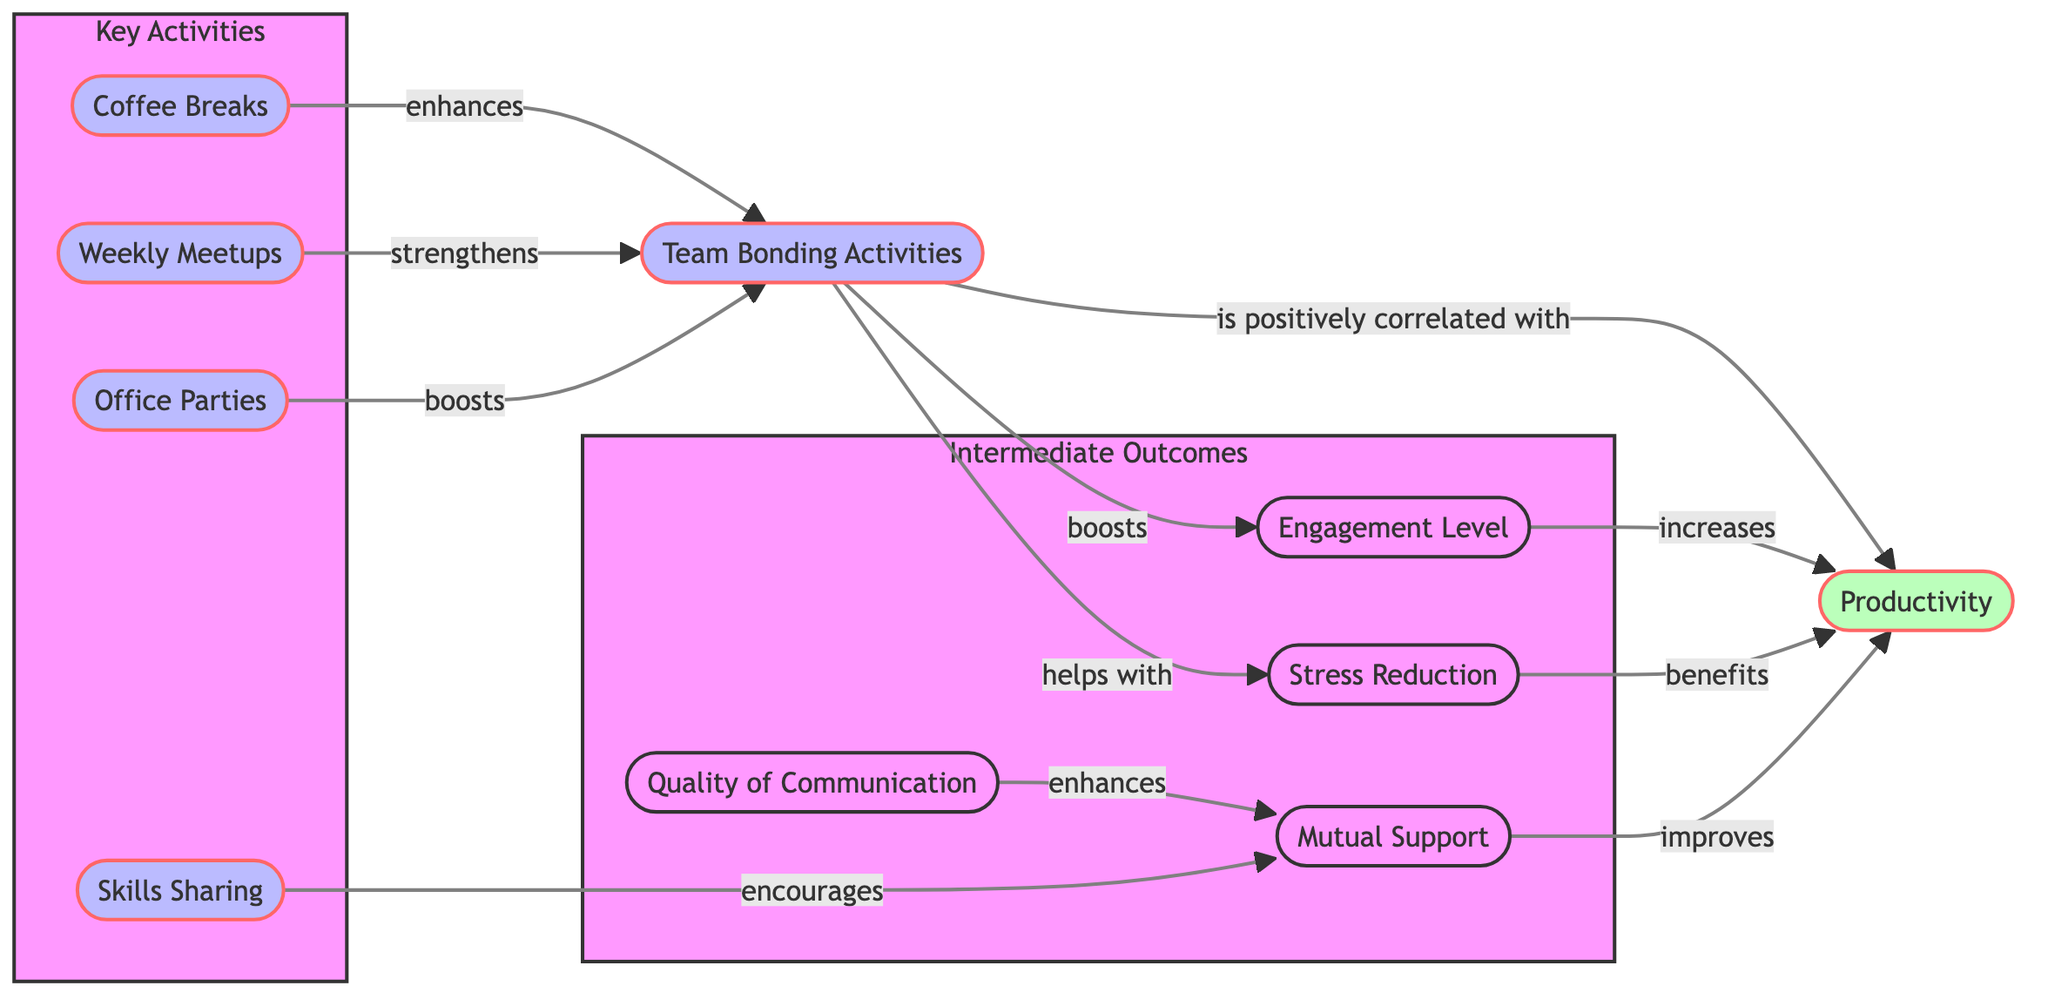What are the main bonding activities mentioned in the diagram? The diagram lists coffee breaks, weekly meetups, office parties, and skills sharing as the main bonding activities under the Key Activities subgraph.
Answer: coffee breaks, weekly meetups, office parties, skills sharing How many outcomes are shown in the diagram? The diagram indicates four outcomes under the Intermediate Outcomes subgraph: mutual support, communication quality, engagement level, and stress reduction.
Answer: four What enhances team bonding according to the diagram? Coffee breaks are shown to enhance team bonding directly in the diagram.
Answer: coffee breaks Which activity is linked to improving productivity through mutual support? The diagram shows that skills sharing encourages mutual support, which in turn improves productivity.
Answer: skills sharing How does team bonding relate to engagement level? According to the diagram, team bonding boosts engagement level, indicating a positive relationship between the two.
Answer: boosts What is the relationship between productivity and team bonding activities? The diagram explicitly states that team bonding activities are positively correlated with productivity, highlighting their impact on performance.
Answer: positively correlated Which intermediate outcome is directly linked to stress reduction? The diagram indicates that stress reduction benefits productivity, showing a direct connection between the two.
Answer: benefits What is the initial node indicating the overall focus of the diagram? The initial node representing the overall focus of the diagram is labeled "Productivity," which is the outcome of interest.
Answer: Productivity Which activity specifically enhances communication quality? The diagram indicates that mutual support enhances communication quality, suggesting a connection between these elements.
Answer: mutual support What contributes to the improvement of mutual support? Communication quality enhances mutual support as shown in the diagram, illustrating the relationship between these two aspects.
Answer: enhances 